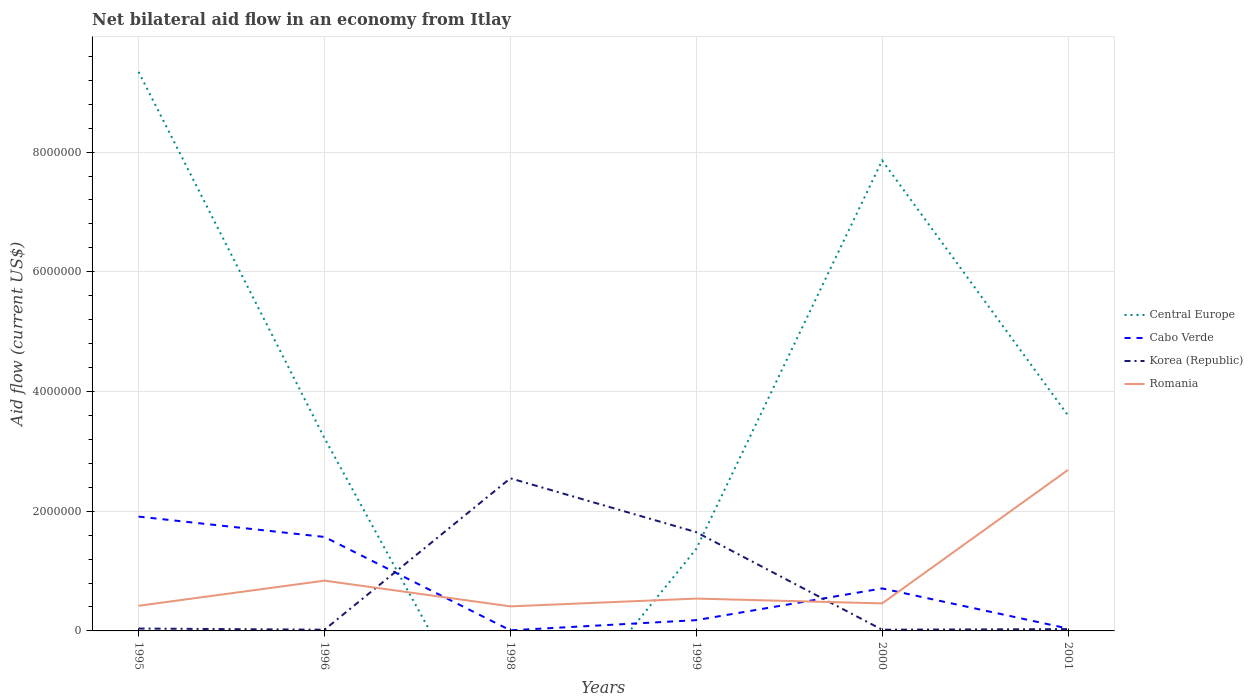What is the total net bilateral aid flow in Korea (Republic) in the graph?
Provide a succinct answer. -1.63e+06. What is the difference between the highest and the second highest net bilateral aid flow in Cabo Verde?
Provide a short and direct response. 1.90e+06. What is the difference between the highest and the lowest net bilateral aid flow in Central Europe?
Offer a very short reply. 2. How many years are there in the graph?
Make the answer very short. 6. Are the values on the major ticks of Y-axis written in scientific E-notation?
Provide a short and direct response. No. Does the graph contain any zero values?
Offer a very short reply. Yes. Does the graph contain grids?
Offer a very short reply. Yes. How many legend labels are there?
Give a very brief answer. 4. How are the legend labels stacked?
Offer a very short reply. Vertical. What is the title of the graph?
Give a very brief answer. Net bilateral aid flow in an economy from Itlay. What is the label or title of the X-axis?
Your answer should be very brief. Years. What is the Aid flow (current US$) of Central Europe in 1995?
Ensure brevity in your answer.  9.34e+06. What is the Aid flow (current US$) in Cabo Verde in 1995?
Provide a short and direct response. 1.91e+06. What is the Aid flow (current US$) of Central Europe in 1996?
Provide a succinct answer. 3.22e+06. What is the Aid flow (current US$) of Cabo Verde in 1996?
Your answer should be very brief. 1.57e+06. What is the Aid flow (current US$) in Korea (Republic) in 1996?
Offer a very short reply. 2.00e+04. What is the Aid flow (current US$) in Romania in 1996?
Provide a succinct answer. 8.40e+05. What is the Aid flow (current US$) in Central Europe in 1998?
Give a very brief answer. 0. What is the Aid flow (current US$) of Korea (Republic) in 1998?
Your answer should be very brief. 2.55e+06. What is the Aid flow (current US$) of Central Europe in 1999?
Offer a terse response. 1.37e+06. What is the Aid flow (current US$) of Korea (Republic) in 1999?
Your answer should be very brief. 1.65e+06. What is the Aid flow (current US$) in Romania in 1999?
Your answer should be very brief. 5.40e+05. What is the Aid flow (current US$) of Central Europe in 2000?
Make the answer very short. 7.86e+06. What is the Aid flow (current US$) in Cabo Verde in 2000?
Keep it short and to the point. 7.10e+05. What is the Aid flow (current US$) in Korea (Republic) in 2000?
Offer a terse response. 2.00e+04. What is the Aid flow (current US$) in Central Europe in 2001?
Offer a very short reply. 3.60e+06. What is the Aid flow (current US$) of Korea (Republic) in 2001?
Give a very brief answer. 3.00e+04. What is the Aid flow (current US$) in Romania in 2001?
Keep it short and to the point. 2.69e+06. Across all years, what is the maximum Aid flow (current US$) in Central Europe?
Your response must be concise. 9.34e+06. Across all years, what is the maximum Aid flow (current US$) in Cabo Verde?
Offer a terse response. 1.91e+06. Across all years, what is the maximum Aid flow (current US$) of Korea (Republic)?
Keep it short and to the point. 2.55e+06. Across all years, what is the maximum Aid flow (current US$) in Romania?
Ensure brevity in your answer.  2.69e+06. Across all years, what is the minimum Aid flow (current US$) of Cabo Verde?
Keep it short and to the point. 10000. What is the total Aid flow (current US$) in Central Europe in the graph?
Keep it short and to the point. 2.54e+07. What is the total Aid flow (current US$) of Cabo Verde in the graph?
Ensure brevity in your answer.  4.42e+06. What is the total Aid flow (current US$) in Korea (Republic) in the graph?
Offer a very short reply. 4.31e+06. What is the total Aid flow (current US$) in Romania in the graph?
Offer a terse response. 5.36e+06. What is the difference between the Aid flow (current US$) in Central Europe in 1995 and that in 1996?
Your response must be concise. 6.12e+06. What is the difference between the Aid flow (current US$) of Cabo Verde in 1995 and that in 1996?
Your answer should be compact. 3.40e+05. What is the difference between the Aid flow (current US$) in Korea (Republic) in 1995 and that in 1996?
Provide a short and direct response. 2.00e+04. What is the difference between the Aid flow (current US$) in Romania in 1995 and that in 1996?
Offer a terse response. -4.20e+05. What is the difference between the Aid flow (current US$) of Cabo Verde in 1995 and that in 1998?
Your answer should be very brief. 1.90e+06. What is the difference between the Aid flow (current US$) in Korea (Republic) in 1995 and that in 1998?
Provide a succinct answer. -2.51e+06. What is the difference between the Aid flow (current US$) of Central Europe in 1995 and that in 1999?
Provide a short and direct response. 7.97e+06. What is the difference between the Aid flow (current US$) in Cabo Verde in 1995 and that in 1999?
Make the answer very short. 1.73e+06. What is the difference between the Aid flow (current US$) in Korea (Republic) in 1995 and that in 1999?
Offer a terse response. -1.61e+06. What is the difference between the Aid flow (current US$) in Central Europe in 1995 and that in 2000?
Provide a short and direct response. 1.48e+06. What is the difference between the Aid flow (current US$) of Cabo Verde in 1995 and that in 2000?
Give a very brief answer. 1.20e+06. What is the difference between the Aid flow (current US$) of Korea (Republic) in 1995 and that in 2000?
Provide a succinct answer. 2.00e+04. What is the difference between the Aid flow (current US$) of Central Europe in 1995 and that in 2001?
Provide a short and direct response. 5.74e+06. What is the difference between the Aid flow (current US$) of Cabo Verde in 1995 and that in 2001?
Offer a very short reply. 1.87e+06. What is the difference between the Aid flow (current US$) in Korea (Republic) in 1995 and that in 2001?
Your response must be concise. 10000. What is the difference between the Aid flow (current US$) of Romania in 1995 and that in 2001?
Your answer should be very brief. -2.27e+06. What is the difference between the Aid flow (current US$) of Cabo Verde in 1996 and that in 1998?
Provide a succinct answer. 1.56e+06. What is the difference between the Aid flow (current US$) in Korea (Republic) in 1996 and that in 1998?
Ensure brevity in your answer.  -2.53e+06. What is the difference between the Aid flow (current US$) in Central Europe in 1996 and that in 1999?
Your response must be concise. 1.85e+06. What is the difference between the Aid flow (current US$) in Cabo Verde in 1996 and that in 1999?
Your answer should be compact. 1.39e+06. What is the difference between the Aid flow (current US$) of Korea (Republic) in 1996 and that in 1999?
Keep it short and to the point. -1.63e+06. What is the difference between the Aid flow (current US$) of Central Europe in 1996 and that in 2000?
Keep it short and to the point. -4.64e+06. What is the difference between the Aid flow (current US$) of Cabo Verde in 1996 and that in 2000?
Your answer should be compact. 8.60e+05. What is the difference between the Aid flow (current US$) of Korea (Republic) in 1996 and that in 2000?
Give a very brief answer. 0. What is the difference between the Aid flow (current US$) in Romania in 1996 and that in 2000?
Make the answer very short. 3.80e+05. What is the difference between the Aid flow (current US$) of Central Europe in 1996 and that in 2001?
Your answer should be compact. -3.80e+05. What is the difference between the Aid flow (current US$) of Cabo Verde in 1996 and that in 2001?
Your answer should be very brief. 1.53e+06. What is the difference between the Aid flow (current US$) in Romania in 1996 and that in 2001?
Give a very brief answer. -1.85e+06. What is the difference between the Aid flow (current US$) in Korea (Republic) in 1998 and that in 1999?
Offer a terse response. 9.00e+05. What is the difference between the Aid flow (current US$) of Cabo Verde in 1998 and that in 2000?
Ensure brevity in your answer.  -7.00e+05. What is the difference between the Aid flow (current US$) of Korea (Republic) in 1998 and that in 2000?
Your answer should be very brief. 2.53e+06. What is the difference between the Aid flow (current US$) of Romania in 1998 and that in 2000?
Keep it short and to the point. -5.00e+04. What is the difference between the Aid flow (current US$) of Cabo Verde in 1998 and that in 2001?
Offer a terse response. -3.00e+04. What is the difference between the Aid flow (current US$) of Korea (Republic) in 1998 and that in 2001?
Your answer should be very brief. 2.52e+06. What is the difference between the Aid flow (current US$) of Romania in 1998 and that in 2001?
Provide a short and direct response. -2.28e+06. What is the difference between the Aid flow (current US$) in Central Europe in 1999 and that in 2000?
Keep it short and to the point. -6.49e+06. What is the difference between the Aid flow (current US$) in Cabo Verde in 1999 and that in 2000?
Offer a terse response. -5.30e+05. What is the difference between the Aid flow (current US$) of Korea (Republic) in 1999 and that in 2000?
Your response must be concise. 1.63e+06. What is the difference between the Aid flow (current US$) in Romania in 1999 and that in 2000?
Provide a short and direct response. 8.00e+04. What is the difference between the Aid flow (current US$) in Central Europe in 1999 and that in 2001?
Make the answer very short. -2.23e+06. What is the difference between the Aid flow (current US$) in Cabo Verde in 1999 and that in 2001?
Keep it short and to the point. 1.40e+05. What is the difference between the Aid flow (current US$) of Korea (Republic) in 1999 and that in 2001?
Ensure brevity in your answer.  1.62e+06. What is the difference between the Aid flow (current US$) in Romania in 1999 and that in 2001?
Your response must be concise. -2.15e+06. What is the difference between the Aid flow (current US$) of Central Europe in 2000 and that in 2001?
Offer a terse response. 4.26e+06. What is the difference between the Aid flow (current US$) of Cabo Verde in 2000 and that in 2001?
Your answer should be very brief. 6.70e+05. What is the difference between the Aid flow (current US$) in Korea (Republic) in 2000 and that in 2001?
Give a very brief answer. -10000. What is the difference between the Aid flow (current US$) in Romania in 2000 and that in 2001?
Ensure brevity in your answer.  -2.23e+06. What is the difference between the Aid flow (current US$) in Central Europe in 1995 and the Aid flow (current US$) in Cabo Verde in 1996?
Your response must be concise. 7.77e+06. What is the difference between the Aid flow (current US$) in Central Europe in 1995 and the Aid flow (current US$) in Korea (Republic) in 1996?
Provide a succinct answer. 9.32e+06. What is the difference between the Aid flow (current US$) in Central Europe in 1995 and the Aid flow (current US$) in Romania in 1996?
Ensure brevity in your answer.  8.50e+06. What is the difference between the Aid flow (current US$) in Cabo Verde in 1995 and the Aid flow (current US$) in Korea (Republic) in 1996?
Your answer should be compact. 1.89e+06. What is the difference between the Aid flow (current US$) of Cabo Verde in 1995 and the Aid flow (current US$) of Romania in 1996?
Ensure brevity in your answer.  1.07e+06. What is the difference between the Aid flow (current US$) of Korea (Republic) in 1995 and the Aid flow (current US$) of Romania in 1996?
Give a very brief answer. -8.00e+05. What is the difference between the Aid flow (current US$) in Central Europe in 1995 and the Aid flow (current US$) in Cabo Verde in 1998?
Your response must be concise. 9.33e+06. What is the difference between the Aid flow (current US$) in Central Europe in 1995 and the Aid flow (current US$) in Korea (Republic) in 1998?
Provide a short and direct response. 6.79e+06. What is the difference between the Aid flow (current US$) of Central Europe in 1995 and the Aid flow (current US$) of Romania in 1998?
Give a very brief answer. 8.93e+06. What is the difference between the Aid flow (current US$) of Cabo Verde in 1995 and the Aid flow (current US$) of Korea (Republic) in 1998?
Your answer should be very brief. -6.40e+05. What is the difference between the Aid flow (current US$) of Cabo Verde in 1995 and the Aid flow (current US$) of Romania in 1998?
Your answer should be compact. 1.50e+06. What is the difference between the Aid flow (current US$) of Korea (Republic) in 1995 and the Aid flow (current US$) of Romania in 1998?
Make the answer very short. -3.70e+05. What is the difference between the Aid flow (current US$) in Central Europe in 1995 and the Aid flow (current US$) in Cabo Verde in 1999?
Offer a very short reply. 9.16e+06. What is the difference between the Aid flow (current US$) of Central Europe in 1995 and the Aid flow (current US$) of Korea (Republic) in 1999?
Keep it short and to the point. 7.69e+06. What is the difference between the Aid flow (current US$) of Central Europe in 1995 and the Aid flow (current US$) of Romania in 1999?
Offer a terse response. 8.80e+06. What is the difference between the Aid flow (current US$) of Cabo Verde in 1995 and the Aid flow (current US$) of Korea (Republic) in 1999?
Provide a short and direct response. 2.60e+05. What is the difference between the Aid flow (current US$) of Cabo Verde in 1995 and the Aid flow (current US$) of Romania in 1999?
Provide a short and direct response. 1.37e+06. What is the difference between the Aid flow (current US$) in Korea (Republic) in 1995 and the Aid flow (current US$) in Romania in 1999?
Ensure brevity in your answer.  -5.00e+05. What is the difference between the Aid flow (current US$) of Central Europe in 1995 and the Aid flow (current US$) of Cabo Verde in 2000?
Make the answer very short. 8.63e+06. What is the difference between the Aid flow (current US$) in Central Europe in 1995 and the Aid flow (current US$) in Korea (Republic) in 2000?
Ensure brevity in your answer.  9.32e+06. What is the difference between the Aid flow (current US$) in Central Europe in 1995 and the Aid flow (current US$) in Romania in 2000?
Make the answer very short. 8.88e+06. What is the difference between the Aid flow (current US$) of Cabo Verde in 1995 and the Aid flow (current US$) of Korea (Republic) in 2000?
Ensure brevity in your answer.  1.89e+06. What is the difference between the Aid flow (current US$) of Cabo Verde in 1995 and the Aid flow (current US$) of Romania in 2000?
Offer a terse response. 1.45e+06. What is the difference between the Aid flow (current US$) in Korea (Republic) in 1995 and the Aid flow (current US$) in Romania in 2000?
Your response must be concise. -4.20e+05. What is the difference between the Aid flow (current US$) in Central Europe in 1995 and the Aid flow (current US$) in Cabo Verde in 2001?
Your response must be concise. 9.30e+06. What is the difference between the Aid flow (current US$) of Central Europe in 1995 and the Aid flow (current US$) of Korea (Republic) in 2001?
Ensure brevity in your answer.  9.31e+06. What is the difference between the Aid flow (current US$) of Central Europe in 1995 and the Aid flow (current US$) of Romania in 2001?
Provide a succinct answer. 6.65e+06. What is the difference between the Aid flow (current US$) of Cabo Verde in 1995 and the Aid flow (current US$) of Korea (Republic) in 2001?
Your answer should be very brief. 1.88e+06. What is the difference between the Aid flow (current US$) in Cabo Verde in 1995 and the Aid flow (current US$) in Romania in 2001?
Offer a terse response. -7.80e+05. What is the difference between the Aid flow (current US$) of Korea (Republic) in 1995 and the Aid flow (current US$) of Romania in 2001?
Your answer should be very brief. -2.65e+06. What is the difference between the Aid flow (current US$) in Central Europe in 1996 and the Aid flow (current US$) in Cabo Verde in 1998?
Your answer should be very brief. 3.21e+06. What is the difference between the Aid flow (current US$) of Central Europe in 1996 and the Aid flow (current US$) of Korea (Republic) in 1998?
Ensure brevity in your answer.  6.70e+05. What is the difference between the Aid flow (current US$) in Central Europe in 1996 and the Aid flow (current US$) in Romania in 1998?
Offer a terse response. 2.81e+06. What is the difference between the Aid flow (current US$) of Cabo Verde in 1996 and the Aid flow (current US$) of Korea (Republic) in 1998?
Make the answer very short. -9.80e+05. What is the difference between the Aid flow (current US$) of Cabo Verde in 1996 and the Aid flow (current US$) of Romania in 1998?
Your response must be concise. 1.16e+06. What is the difference between the Aid flow (current US$) of Korea (Republic) in 1996 and the Aid flow (current US$) of Romania in 1998?
Provide a short and direct response. -3.90e+05. What is the difference between the Aid flow (current US$) in Central Europe in 1996 and the Aid flow (current US$) in Cabo Verde in 1999?
Provide a short and direct response. 3.04e+06. What is the difference between the Aid flow (current US$) in Central Europe in 1996 and the Aid flow (current US$) in Korea (Republic) in 1999?
Provide a succinct answer. 1.57e+06. What is the difference between the Aid flow (current US$) in Central Europe in 1996 and the Aid flow (current US$) in Romania in 1999?
Ensure brevity in your answer.  2.68e+06. What is the difference between the Aid flow (current US$) in Cabo Verde in 1996 and the Aid flow (current US$) in Romania in 1999?
Your answer should be very brief. 1.03e+06. What is the difference between the Aid flow (current US$) of Korea (Republic) in 1996 and the Aid flow (current US$) of Romania in 1999?
Ensure brevity in your answer.  -5.20e+05. What is the difference between the Aid flow (current US$) in Central Europe in 1996 and the Aid flow (current US$) in Cabo Verde in 2000?
Offer a terse response. 2.51e+06. What is the difference between the Aid flow (current US$) in Central Europe in 1996 and the Aid flow (current US$) in Korea (Republic) in 2000?
Your answer should be very brief. 3.20e+06. What is the difference between the Aid flow (current US$) in Central Europe in 1996 and the Aid flow (current US$) in Romania in 2000?
Your answer should be compact. 2.76e+06. What is the difference between the Aid flow (current US$) of Cabo Verde in 1996 and the Aid flow (current US$) of Korea (Republic) in 2000?
Ensure brevity in your answer.  1.55e+06. What is the difference between the Aid flow (current US$) of Cabo Verde in 1996 and the Aid flow (current US$) of Romania in 2000?
Provide a succinct answer. 1.11e+06. What is the difference between the Aid flow (current US$) in Korea (Republic) in 1996 and the Aid flow (current US$) in Romania in 2000?
Provide a succinct answer. -4.40e+05. What is the difference between the Aid flow (current US$) in Central Europe in 1996 and the Aid flow (current US$) in Cabo Verde in 2001?
Your answer should be very brief. 3.18e+06. What is the difference between the Aid flow (current US$) in Central Europe in 1996 and the Aid flow (current US$) in Korea (Republic) in 2001?
Offer a terse response. 3.19e+06. What is the difference between the Aid flow (current US$) of Central Europe in 1996 and the Aid flow (current US$) of Romania in 2001?
Offer a terse response. 5.30e+05. What is the difference between the Aid flow (current US$) of Cabo Verde in 1996 and the Aid flow (current US$) of Korea (Republic) in 2001?
Offer a very short reply. 1.54e+06. What is the difference between the Aid flow (current US$) in Cabo Verde in 1996 and the Aid flow (current US$) in Romania in 2001?
Ensure brevity in your answer.  -1.12e+06. What is the difference between the Aid flow (current US$) in Korea (Republic) in 1996 and the Aid flow (current US$) in Romania in 2001?
Provide a short and direct response. -2.67e+06. What is the difference between the Aid flow (current US$) of Cabo Verde in 1998 and the Aid flow (current US$) of Korea (Republic) in 1999?
Ensure brevity in your answer.  -1.64e+06. What is the difference between the Aid flow (current US$) in Cabo Verde in 1998 and the Aid flow (current US$) in Romania in 1999?
Offer a terse response. -5.30e+05. What is the difference between the Aid flow (current US$) of Korea (Republic) in 1998 and the Aid flow (current US$) of Romania in 1999?
Keep it short and to the point. 2.01e+06. What is the difference between the Aid flow (current US$) in Cabo Verde in 1998 and the Aid flow (current US$) in Korea (Republic) in 2000?
Keep it short and to the point. -10000. What is the difference between the Aid flow (current US$) in Cabo Verde in 1998 and the Aid flow (current US$) in Romania in 2000?
Give a very brief answer. -4.50e+05. What is the difference between the Aid flow (current US$) in Korea (Republic) in 1998 and the Aid flow (current US$) in Romania in 2000?
Provide a short and direct response. 2.09e+06. What is the difference between the Aid flow (current US$) of Cabo Verde in 1998 and the Aid flow (current US$) of Korea (Republic) in 2001?
Your answer should be compact. -2.00e+04. What is the difference between the Aid flow (current US$) in Cabo Verde in 1998 and the Aid flow (current US$) in Romania in 2001?
Make the answer very short. -2.68e+06. What is the difference between the Aid flow (current US$) in Korea (Republic) in 1998 and the Aid flow (current US$) in Romania in 2001?
Give a very brief answer. -1.40e+05. What is the difference between the Aid flow (current US$) of Central Europe in 1999 and the Aid flow (current US$) of Cabo Verde in 2000?
Ensure brevity in your answer.  6.60e+05. What is the difference between the Aid flow (current US$) in Central Europe in 1999 and the Aid flow (current US$) in Korea (Republic) in 2000?
Your response must be concise. 1.35e+06. What is the difference between the Aid flow (current US$) in Central Europe in 1999 and the Aid flow (current US$) in Romania in 2000?
Your answer should be compact. 9.10e+05. What is the difference between the Aid flow (current US$) of Cabo Verde in 1999 and the Aid flow (current US$) of Romania in 2000?
Your answer should be very brief. -2.80e+05. What is the difference between the Aid flow (current US$) of Korea (Republic) in 1999 and the Aid flow (current US$) of Romania in 2000?
Provide a succinct answer. 1.19e+06. What is the difference between the Aid flow (current US$) of Central Europe in 1999 and the Aid flow (current US$) of Cabo Verde in 2001?
Your answer should be very brief. 1.33e+06. What is the difference between the Aid flow (current US$) of Central Europe in 1999 and the Aid flow (current US$) of Korea (Republic) in 2001?
Your response must be concise. 1.34e+06. What is the difference between the Aid flow (current US$) in Central Europe in 1999 and the Aid flow (current US$) in Romania in 2001?
Keep it short and to the point. -1.32e+06. What is the difference between the Aid flow (current US$) in Cabo Verde in 1999 and the Aid flow (current US$) in Korea (Republic) in 2001?
Give a very brief answer. 1.50e+05. What is the difference between the Aid flow (current US$) in Cabo Verde in 1999 and the Aid flow (current US$) in Romania in 2001?
Ensure brevity in your answer.  -2.51e+06. What is the difference between the Aid flow (current US$) of Korea (Republic) in 1999 and the Aid flow (current US$) of Romania in 2001?
Provide a succinct answer. -1.04e+06. What is the difference between the Aid flow (current US$) in Central Europe in 2000 and the Aid flow (current US$) in Cabo Verde in 2001?
Your answer should be compact. 7.82e+06. What is the difference between the Aid flow (current US$) in Central Europe in 2000 and the Aid flow (current US$) in Korea (Republic) in 2001?
Your answer should be very brief. 7.83e+06. What is the difference between the Aid flow (current US$) in Central Europe in 2000 and the Aid flow (current US$) in Romania in 2001?
Offer a terse response. 5.17e+06. What is the difference between the Aid flow (current US$) of Cabo Verde in 2000 and the Aid flow (current US$) of Korea (Republic) in 2001?
Provide a short and direct response. 6.80e+05. What is the difference between the Aid flow (current US$) in Cabo Verde in 2000 and the Aid flow (current US$) in Romania in 2001?
Provide a succinct answer. -1.98e+06. What is the difference between the Aid flow (current US$) of Korea (Republic) in 2000 and the Aid flow (current US$) of Romania in 2001?
Your answer should be very brief. -2.67e+06. What is the average Aid flow (current US$) of Central Europe per year?
Provide a short and direct response. 4.23e+06. What is the average Aid flow (current US$) in Cabo Verde per year?
Your response must be concise. 7.37e+05. What is the average Aid flow (current US$) in Korea (Republic) per year?
Your response must be concise. 7.18e+05. What is the average Aid flow (current US$) of Romania per year?
Offer a terse response. 8.93e+05. In the year 1995, what is the difference between the Aid flow (current US$) in Central Europe and Aid flow (current US$) in Cabo Verde?
Ensure brevity in your answer.  7.43e+06. In the year 1995, what is the difference between the Aid flow (current US$) of Central Europe and Aid flow (current US$) of Korea (Republic)?
Offer a terse response. 9.30e+06. In the year 1995, what is the difference between the Aid flow (current US$) of Central Europe and Aid flow (current US$) of Romania?
Offer a very short reply. 8.92e+06. In the year 1995, what is the difference between the Aid flow (current US$) of Cabo Verde and Aid flow (current US$) of Korea (Republic)?
Offer a terse response. 1.87e+06. In the year 1995, what is the difference between the Aid flow (current US$) in Cabo Verde and Aid flow (current US$) in Romania?
Your answer should be compact. 1.49e+06. In the year 1995, what is the difference between the Aid flow (current US$) in Korea (Republic) and Aid flow (current US$) in Romania?
Ensure brevity in your answer.  -3.80e+05. In the year 1996, what is the difference between the Aid flow (current US$) of Central Europe and Aid flow (current US$) of Cabo Verde?
Your answer should be compact. 1.65e+06. In the year 1996, what is the difference between the Aid flow (current US$) of Central Europe and Aid flow (current US$) of Korea (Republic)?
Make the answer very short. 3.20e+06. In the year 1996, what is the difference between the Aid flow (current US$) of Central Europe and Aid flow (current US$) of Romania?
Give a very brief answer. 2.38e+06. In the year 1996, what is the difference between the Aid flow (current US$) in Cabo Verde and Aid flow (current US$) in Korea (Republic)?
Make the answer very short. 1.55e+06. In the year 1996, what is the difference between the Aid flow (current US$) of Cabo Verde and Aid flow (current US$) of Romania?
Provide a succinct answer. 7.30e+05. In the year 1996, what is the difference between the Aid flow (current US$) of Korea (Republic) and Aid flow (current US$) of Romania?
Your answer should be compact. -8.20e+05. In the year 1998, what is the difference between the Aid flow (current US$) of Cabo Verde and Aid flow (current US$) of Korea (Republic)?
Offer a very short reply. -2.54e+06. In the year 1998, what is the difference between the Aid flow (current US$) in Cabo Verde and Aid flow (current US$) in Romania?
Your answer should be very brief. -4.00e+05. In the year 1998, what is the difference between the Aid flow (current US$) in Korea (Republic) and Aid flow (current US$) in Romania?
Give a very brief answer. 2.14e+06. In the year 1999, what is the difference between the Aid flow (current US$) in Central Europe and Aid flow (current US$) in Cabo Verde?
Your answer should be very brief. 1.19e+06. In the year 1999, what is the difference between the Aid flow (current US$) of Central Europe and Aid flow (current US$) of Korea (Republic)?
Ensure brevity in your answer.  -2.80e+05. In the year 1999, what is the difference between the Aid flow (current US$) in Central Europe and Aid flow (current US$) in Romania?
Your answer should be very brief. 8.30e+05. In the year 1999, what is the difference between the Aid flow (current US$) in Cabo Verde and Aid flow (current US$) in Korea (Republic)?
Keep it short and to the point. -1.47e+06. In the year 1999, what is the difference between the Aid flow (current US$) of Cabo Verde and Aid flow (current US$) of Romania?
Offer a very short reply. -3.60e+05. In the year 1999, what is the difference between the Aid flow (current US$) of Korea (Republic) and Aid flow (current US$) of Romania?
Make the answer very short. 1.11e+06. In the year 2000, what is the difference between the Aid flow (current US$) of Central Europe and Aid flow (current US$) of Cabo Verde?
Offer a terse response. 7.15e+06. In the year 2000, what is the difference between the Aid flow (current US$) of Central Europe and Aid flow (current US$) of Korea (Republic)?
Your response must be concise. 7.84e+06. In the year 2000, what is the difference between the Aid flow (current US$) in Central Europe and Aid flow (current US$) in Romania?
Keep it short and to the point. 7.40e+06. In the year 2000, what is the difference between the Aid flow (current US$) in Cabo Verde and Aid flow (current US$) in Korea (Republic)?
Give a very brief answer. 6.90e+05. In the year 2000, what is the difference between the Aid flow (current US$) in Cabo Verde and Aid flow (current US$) in Romania?
Keep it short and to the point. 2.50e+05. In the year 2000, what is the difference between the Aid flow (current US$) in Korea (Republic) and Aid flow (current US$) in Romania?
Offer a very short reply. -4.40e+05. In the year 2001, what is the difference between the Aid flow (current US$) of Central Europe and Aid flow (current US$) of Cabo Verde?
Keep it short and to the point. 3.56e+06. In the year 2001, what is the difference between the Aid flow (current US$) of Central Europe and Aid flow (current US$) of Korea (Republic)?
Keep it short and to the point. 3.57e+06. In the year 2001, what is the difference between the Aid flow (current US$) in Central Europe and Aid flow (current US$) in Romania?
Keep it short and to the point. 9.10e+05. In the year 2001, what is the difference between the Aid flow (current US$) of Cabo Verde and Aid flow (current US$) of Romania?
Ensure brevity in your answer.  -2.65e+06. In the year 2001, what is the difference between the Aid flow (current US$) in Korea (Republic) and Aid flow (current US$) in Romania?
Make the answer very short. -2.66e+06. What is the ratio of the Aid flow (current US$) in Central Europe in 1995 to that in 1996?
Keep it short and to the point. 2.9. What is the ratio of the Aid flow (current US$) in Cabo Verde in 1995 to that in 1996?
Your response must be concise. 1.22. What is the ratio of the Aid flow (current US$) of Romania in 1995 to that in 1996?
Provide a succinct answer. 0.5. What is the ratio of the Aid flow (current US$) of Cabo Verde in 1995 to that in 1998?
Your answer should be compact. 191. What is the ratio of the Aid flow (current US$) in Korea (Republic) in 1995 to that in 1998?
Make the answer very short. 0.02. What is the ratio of the Aid flow (current US$) in Romania in 1995 to that in 1998?
Provide a short and direct response. 1.02. What is the ratio of the Aid flow (current US$) of Central Europe in 1995 to that in 1999?
Keep it short and to the point. 6.82. What is the ratio of the Aid flow (current US$) of Cabo Verde in 1995 to that in 1999?
Ensure brevity in your answer.  10.61. What is the ratio of the Aid flow (current US$) in Korea (Republic) in 1995 to that in 1999?
Your response must be concise. 0.02. What is the ratio of the Aid flow (current US$) in Romania in 1995 to that in 1999?
Provide a succinct answer. 0.78. What is the ratio of the Aid flow (current US$) in Central Europe in 1995 to that in 2000?
Offer a very short reply. 1.19. What is the ratio of the Aid flow (current US$) of Cabo Verde in 1995 to that in 2000?
Make the answer very short. 2.69. What is the ratio of the Aid flow (current US$) in Central Europe in 1995 to that in 2001?
Provide a succinct answer. 2.59. What is the ratio of the Aid flow (current US$) in Cabo Verde in 1995 to that in 2001?
Make the answer very short. 47.75. What is the ratio of the Aid flow (current US$) in Romania in 1995 to that in 2001?
Provide a succinct answer. 0.16. What is the ratio of the Aid flow (current US$) of Cabo Verde in 1996 to that in 1998?
Offer a terse response. 157. What is the ratio of the Aid flow (current US$) of Korea (Republic) in 1996 to that in 1998?
Provide a succinct answer. 0.01. What is the ratio of the Aid flow (current US$) of Romania in 1996 to that in 1998?
Ensure brevity in your answer.  2.05. What is the ratio of the Aid flow (current US$) of Central Europe in 1996 to that in 1999?
Your response must be concise. 2.35. What is the ratio of the Aid flow (current US$) in Cabo Verde in 1996 to that in 1999?
Provide a succinct answer. 8.72. What is the ratio of the Aid flow (current US$) in Korea (Republic) in 1996 to that in 1999?
Ensure brevity in your answer.  0.01. What is the ratio of the Aid flow (current US$) of Romania in 1996 to that in 1999?
Your answer should be compact. 1.56. What is the ratio of the Aid flow (current US$) in Central Europe in 1996 to that in 2000?
Your answer should be compact. 0.41. What is the ratio of the Aid flow (current US$) in Cabo Verde in 1996 to that in 2000?
Make the answer very short. 2.21. What is the ratio of the Aid flow (current US$) in Korea (Republic) in 1996 to that in 2000?
Offer a terse response. 1. What is the ratio of the Aid flow (current US$) of Romania in 1996 to that in 2000?
Give a very brief answer. 1.83. What is the ratio of the Aid flow (current US$) in Central Europe in 1996 to that in 2001?
Offer a very short reply. 0.89. What is the ratio of the Aid flow (current US$) in Cabo Verde in 1996 to that in 2001?
Offer a terse response. 39.25. What is the ratio of the Aid flow (current US$) in Romania in 1996 to that in 2001?
Ensure brevity in your answer.  0.31. What is the ratio of the Aid flow (current US$) of Cabo Verde in 1998 to that in 1999?
Provide a succinct answer. 0.06. What is the ratio of the Aid flow (current US$) in Korea (Republic) in 1998 to that in 1999?
Keep it short and to the point. 1.55. What is the ratio of the Aid flow (current US$) in Romania in 1998 to that in 1999?
Ensure brevity in your answer.  0.76. What is the ratio of the Aid flow (current US$) of Cabo Verde in 1998 to that in 2000?
Ensure brevity in your answer.  0.01. What is the ratio of the Aid flow (current US$) of Korea (Republic) in 1998 to that in 2000?
Your response must be concise. 127.5. What is the ratio of the Aid flow (current US$) of Romania in 1998 to that in 2000?
Offer a very short reply. 0.89. What is the ratio of the Aid flow (current US$) in Cabo Verde in 1998 to that in 2001?
Offer a very short reply. 0.25. What is the ratio of the Aid flow (current US$) of Korea (Republic) in 1998 to that in 2001?
Your answer should be very brief. 85. What is the ratio of the Aid flow (current US$) in Romania in 1998 to that in 2001?
Ensure brevity in your answer.  0.15. What is the ratio of the Aid flow (current US$) in Central Europe in 1999 to that in 2000?
Provide a short and direct response. 0.17. What is the ratio of the Aid flow (current US$) of Cabo Verde in 1999 to that in 2000?
Your answer should be very brief. 0.25. What is the ratio of the Aid flow (current US$) of Korea (Republic) in 1999 to that in 2000?
Offer a very short reply. 82.5. What is the ratio of the Aid flow (current US$) of Romania in 1999 to that in 2000?
Keep it short and to the point. 1.17. What is the ratio of the Aid flow (current US$) of Central Europe in 1999 to that in 2001?
Make the answer very short. 0.38. What is the ratio of the Aid flow (current US$) in Cabo Verde in 1999 to that in 2001?
Give a very brief answer. 4.5. What is the ratio of the Aid flow (current US$) of Korea (Republic) in 1999 to that in 2001?
Your answer should be very brief. 55. What is the ratio of the Aid flow (current US$) in Romania in 1999 to that in 2001?
Offer a terse response. 0.2. What is the ratio of the Aid flow (current US$) of Central Europe in 2000 to that in 2001?
Ensure brevity in your answer.  2.18. What is the ratio of the Aid flow (current US$) in Cabo Verde in 2000 to that in 2001?
Keep it short and to the point. 17.75. What is the ratio of the Aid flow (current US$) in Korea (Republic) in 2000 to that in 2001?
Offer a very short reply. 0.67. What is the ratio of the Aid flow (current US$) in Romania in 2000 to that in 2001?
Your response must be concise. 0.17. What is the difference between the highest and the second highest Aid flow (current US$) of Central Europe?
Make the answer very short. 1.48e+06. What is the difference between the highest and the second highest Aid flow (current US$) of Cabo Verde?
Make the answer very short. 3.40e+05. What is the difference between the highest and the second highest Aid flow (current US$) of Romania?
Make the answer very short. 1.85e+06. What is the difference between the highest and the lowest Aid flow (current US$) in Central Europe?
Ensure brevity in your answer.  9.34e+06. What is the difference between the highest and the lowest Aid flow (current US$) in Cabo Verde?
Ensure brevity in your answer.  1.90e+06. What is the difference between the highest and the lowest Aid flow (current US$) in Korea (Republic)?
Offer a very short reply. 2.53e+06. What is the difference between the highest and the lowest Aid flow (current US$) in Romania?
Your answer should be compact. 2.28e+06. 